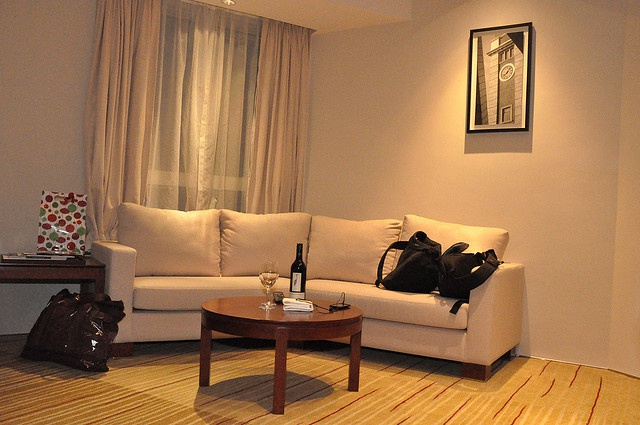Describe the objects in this image and their specific colors. I can see couch in brown, gray, tan, and black tones, handbag in brown, black, tan, maroon, and salmon tones, backpack in brown, black, tan, maroon, and salmon tones, backpack in brown, black, maroon, and khaki tones, and handbag in brown, black, maroon, and gray tones in this image. 